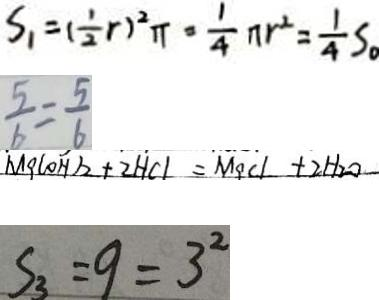Convert formula to latex. <formula><loc_0><loc_0><loc_500><loc_500>S _ { 1 } = ( \frac { 1 } { 2 } r ) ^ { 2 } \pi = \frac { 1 } { 4 } \pi r ^ { 2 } = \frac { 1 } { 4 } S _ { \circ } 
 \frac { 5 } { b } = \frac { 5 } { 6 } 
 M g ( O H ) _ { 2 } + 2 H C l = M g C l + 2 H _ { 2 } O 
 S _ { 3 } = 9 = 3 ^ { 2 }</formula> 